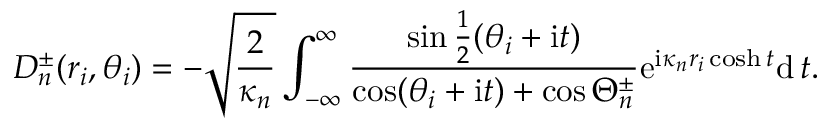<formula> <loc_0><loc_0><loc_500><loc_500>D _ { n } ^ { \pm } ( r _ { i } , \theta _ { i } ) = - \sqrt { \frac { 2 } { \kappa _ { n } } } \int _ { - \infty } ^ { \infty } \frac { \sin \frac { 1 } { 2 } ( \theta _ { i } + i t ) } { \cos ( \theta _ { i } + i t ) + \cos \Theta _ { n } ^ { \pm } } e ^ { i \kappa _ { n } r _ { i } \cosh t } d \, t .</formula> 